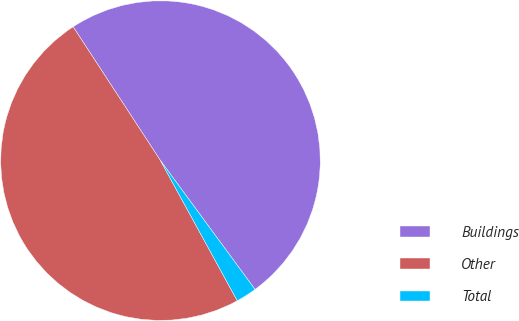<chart> <loc_0><loc_0><loc_500><loc_500><pie_chart><fcel>Buildings<fcel>Other<fcel>Total<nl><fcel>49.13%<fcel>48.78%<fcel>2.1%<nl></chart> 